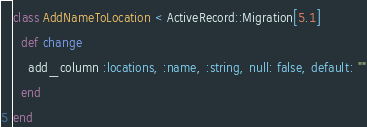<code> <loc_0><loc_0><loc_500><loc_500><_Ruby_>class AddNameToLocation < ActiveRecord::Migration[5.1]
  def change
    add_column :locations, :name, :string, null: false, default: ""
  end
end
</code> 